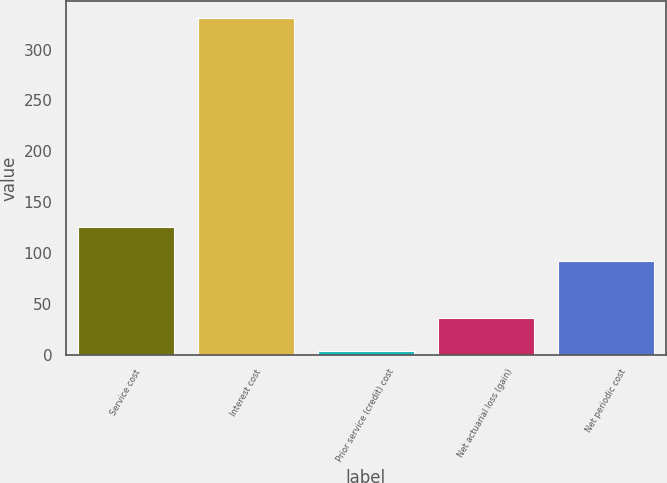Convert chart. <chart><loc_0><loc_0><loc_500><loc_500><bar_chart><fcel>Service cost<fcel>Interest cost<fcel>Prior service (credit) cost<fcel>Net actuarial loss (gain)<fcel>Net periodic cost<nl><fcel>125<fcel>331<fcel>3<fcel>35.8<fcel>92<nl></chart> 